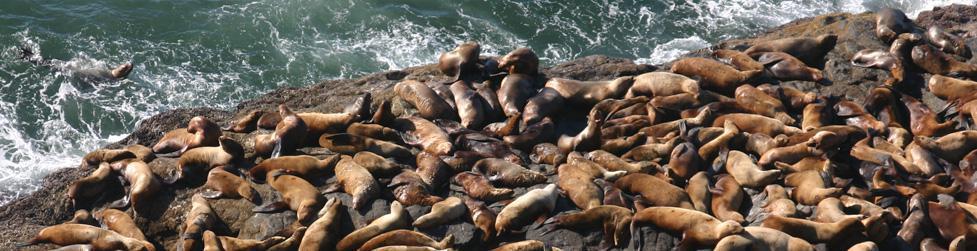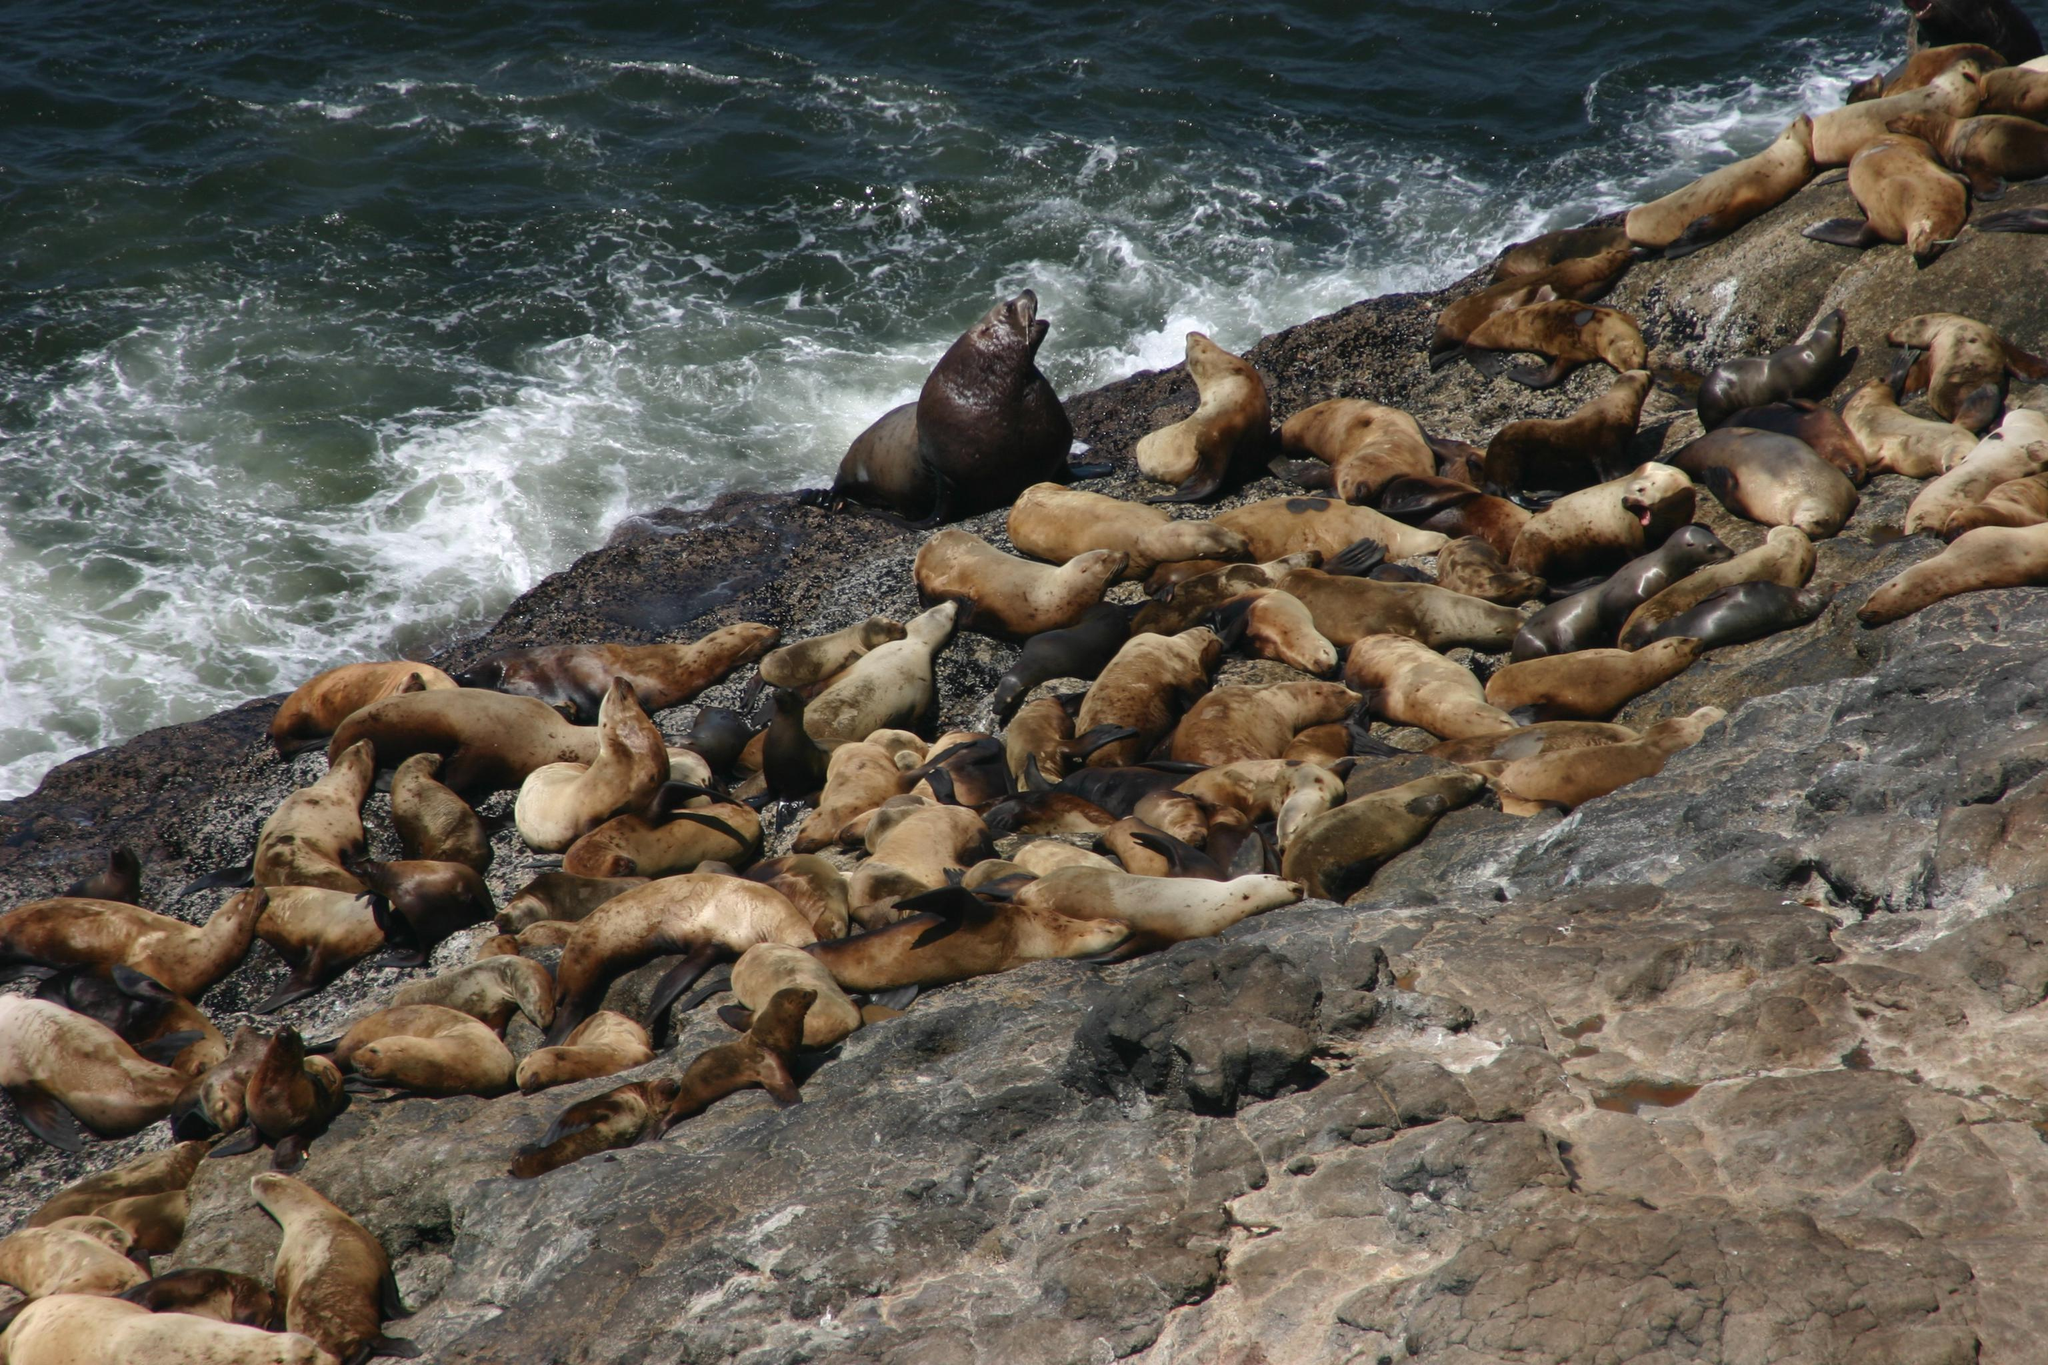The first image is the image on the left, the second image is the image on the right. For the images displayed, is the sentence "light spills through a small hole in the cave wall in the image on the right." factually correct? Answer yes or no. No. 